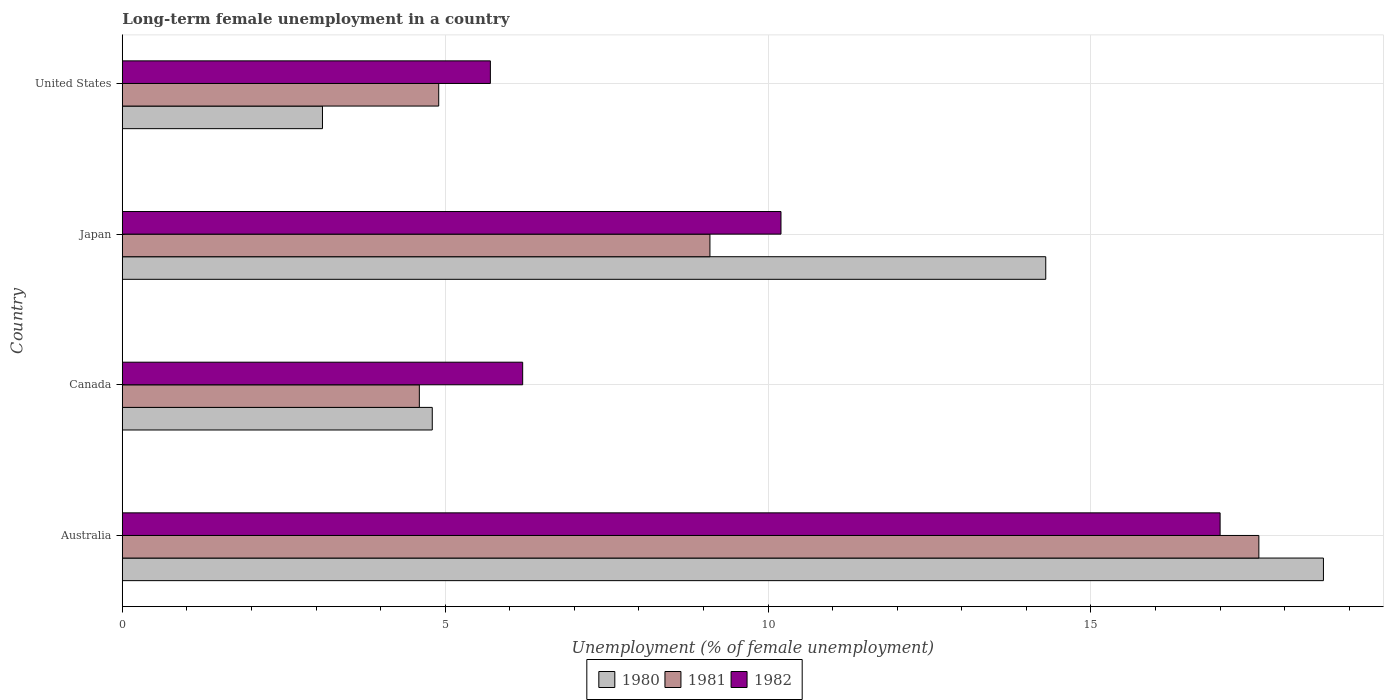How many bars are there on the 1st tick from the bottom?
Offer a very short reply. 3. In how many cases, is the number of bars for a given country not equal to the number of legend labels?
Provide a short and direct response. 0. Across all countries, what is the maximum percentage of long-term unemployed female population in 1980?
Offer a very short reply. 18.6. Across all countries, what is the minimum percentage of long-term unemployed female population in 1980?
Make the answer very short. 3.1. In which country was the percentage of long-term unemployed female population in 1981 maximum?
Your answer should be very brief. Australia. In which country was the percentage of long-term unemployed female population in 1982 minimum?
Provide a short and direct response. United States. What is the total percentage of long-term unemployed female population in 1981 in the graph?
Provide a short and direct response. 36.2. What is the difference between the percentage of long-term unemployed female population in 1980 in Australia and that in United States?
Ensure brevity in your answer.  15.5. What is the difference between the percentage of long-term unemployed female population in 1982 in United States and the percentage of long-term unemployed female population in 1981 in Australia?
Provide a short and direct response. -11.9. What is the average percentage of long-term unemployed female population in 1980 per country?
Your answer should be very brief. 10.2. What is the difference between the percentage of long-term unemployed female population in 1981 and percentage of long-term unemployed female population in 1980 in United States?
Your answer should be compact. 1.8. What is the ratio of the percentage of long-term unemployed female population in 1980 in Japan to that in United States?
Ensure brevity in your answer.  4.61. What is the difference between the highest and the second highest percentage of long-term unemployed female population in 1982?
Your answer should be very brief. 6.8. What is the difference between the highest and the lowest percentage of long-term unemployed female population in 1980?
Ensure brevity in your answer.  15.5. In how many countries, is the percentage of long-term unemployed female population in 1982 greater than the average percentage of long-term unemployed female population in 1982 taken over all countries?
Ensure brevity in your answer.  2. Is the sum of the percentage of long-term unemployed female population in 1982 in Australia and Canada greater than the maximum percentage of long-term unemployed female population in 1981 across all countries?
Make the answer very short. Yes. What does the 3rd bar from the top in Canada represents?
Make the answer very short. 1980. Is it the case that in every country, the sum of the percentage of long-term unemployed female population in 1982 and percentage of long-term unemployed female population in 1981 is greater than the percentage of long-term unemployed female population in 1980?
Offer a terse response. Yes. Are all the bars in the graph horizontal?
Provide a short and direct response. Yes. How many countries are there in the graph?
Give a very brief answer. 4. Are the values on the major ticks of X-axis written in scientific E-notation?
Offer a terse response. No. Does the graph contain any zero values?
Provide a succinct answer. No. How many legend labels are there?
Your answer should be very brief. 3. How are the legend labels stacked?
Provide a succinct answer. Horizontal. What is the title of the graph?
Provide a short and direct response. Long-term female unemployment in a country. Does "1981" appear as one of the legend labels in the graph?
Ensure brevity in your answer.  Yes. What is the label or title of the X-axis?
Your answer should be very brief. Unemployment (% of female unemployment). What is the Unemployment (% of female unemployment) in 1980 in Australia?
Keep it short and to the point. 18.6. What is the Unemployment (% of female unemployment) of 1981 in Australia?
Offer a very short reply. 17.6. What is the Unemployment (% of female unemployment) of 1982 in Australia?
Keep it short and to the point. 17. What is the Unemployment (% of female unemployment) of 1980 in Canada?
Provide a succinct answer. 4.8. What is the Unemployment (% of female unemployment) of 1981 in Canada?
Provide a succinct answer. 4.6. What is the Unemployment (% of female unemployment) in 1982 in Canada?
Keep it short and to the point. 6.2. What is the Unemployment (% of female unemployment) of 1980 in Japan?
Ensure brevity in your answer.  14.3. What is the Unemployment (% of female unemployment) in 1981 in Japan?
Offer a terse response. 9.1. What is the Unemployment (% of female unemployment) of 1982 in Japan?
Give a very brief answer. 10.2. What is the Unemployment (% of female unemployment) of 1980 in United States?
Your answer should be very brief. 3.1. What is the Unemployment (% of female unemployment) of 1981 in United States?
Offer a very short reply. 4.9. What is the Unemployment (% of female unemployment) in 1982 in United States?
Offer a terse response. 5.7. Across all countries, what is the maximum Unemployment (% of female unemployment) in 1980?
Keep it short and to the point. 18.6. Across all countries, what is the maximum Unemployment (% of female unemployment) in 1981?
Offer a terse response. 17.6. Across all countries, what is the minimum Unemployment (% of female unemployment) in 1980?
Make the answer very short. 3.1. Across all countries, what is the minimum Unemployment (% of female unemployment) in 1981?
Ensure brevity in your answer.  4.6. Across all countries, what is the minimum Unemployment (% of female unemployment) in 1982?
Your answer should be very brief. 5.7. What is the total Unemployment (% of female unemployment) of 1980 in the graph?
Your answer should be compact. 40.8. What is the total Unemployment (% of female unemployment) of 1981 in the graph?
Provide a short and direct response. 36.2. What is the total Unemployment (% of female unemployment) in 1982 in the graph?
Make the answer very short. 39.1. What is the difference between the Unemployment (% of female unemployment) of 1980 in Australia and that in Canada?
Make the answer very short. 13.8. What is the difference between the Unemployment (% of female unemployment) in 1981 in Australia and that in Japan?
Offer a very short reply. 8.5. What is the difference between the Unemployment (% of female unemployment) of 1982 in Australia and that in Japan?
Provide a succinct answer. 6.8. What is the difference between the Unemployment (% of female unemployment) of 1980 in Australia and that in United States?
Provide a short and direct response. 15.5. What is the difference between the Unemployment (% of female unemployment) of 1980 in Canada and that in United States?
Provide a short and direct response. 1.7. What is the difference between the Unemployment (% of female unemployment) in 1981 in Canada and that in United States?
Offer a very short reply. -0.3. What is the difference between the Unemployment (% of female unemployment) in 1982 in Canada and that in United States?
Offer a terse response. 0.5. What is the difference between the Unemployment (% of female unemployment) of 1981 in Japan and that in United States?
Make the answer very short. 4.2. What is the difference between the Unemployment (% of female unemployment) in 1982 in Japan and that in United States?
Offer a very short reply. 4.5. What is the difference between the Unemployment (% of female unemployment) of 1980 in Australia and the Unemployment (% of female unemployment) of 1982 in Canada?
Give a very brief answer. 12.4. What is the difference between the Unemployment (% of female unemployment) in 1981 in Australia and the Unemployment (% of female unemployment) in 1982 in Canada?
Your response must be concise. 11.4. What is the difference between the Unemployment (% of female unemployment) in 1981 in Australia and the Unemployment (% of female unemployment) in 1982 in Japan?
Ensure brevity in your answer.  7.4. What is the difference between the Unemployment (% of female unemployment) of 1980 in Australia and the Unemployment (% of female unemployment) of 1982 in United States?
Your answer should be very brief. 12.9. What is the difference between the Unemployment (% of female unemployment) of 1980 in Canada and the Unemployment (% of female unemployment) of 1982 in Japan?
Your answer should be very brief. -5.4. What is the difference between the Unemployment (% of female unemployment) of 1980 in Canada and the Unemployment (% of female unemployment) of 1981 in United States?
Offer a very short reply. -0.1. What is the difference between the Unemployment (% of female unemployment) of 1981 in Canada and the Unemployment (% of female unemployment) of 1982 in United States?
Ensure brevity in your answer.  -1.1. What is the average Unemployment (% of female unemployment) in 1980 per country?
Your response must be concise. 10.2. What is the average Unemployment (% of female unemployment) in 1981 per country?
Provide a succinct answer. 9.05. What is the average Unemployment (% of female unemployment) of 1982 per country?
Provide a short and direct response. 9.78. What is the difference between the Unemployment (% of female unemployment) of 1980 and Unemployment (% of female unemployment) of 1982 in Australia?
Your answer should be compact. 1.6. What is the difference between the Unemployment (% of female unemployment) in 1980 and Unemployment (% of female unemployment) in 1981 in Canada?
Provide a succinct answer. 0.2. What is the difference between the Unemployment (% of female unemployment) in 1980 and Unemployment (% of female unemployment) in 1982 in Canada?
Offer a very short reply. -1.4. What is the difference between the Unemployment (% of female unemployment) in 1980 and Unemployment (% of female unemployment) in 1981 in Japan?
Provide a succinct answer. 5.2. What is the difference between the Unemployment (% of female unemployment) in 1981 and Unemployment (% of female unemployment) in 1982 in Japan?
Your answer should be very brief. -1.1. What is the difference between the Unemployment (% of female unemployment) in 1980 and Unemployment (% of female unemployment) in 1982 in United States?
Offer a very short reply. -2.6. What is the ratio of the Unemployment (% of female unemployment) of 1980 in Australia to that in Canada?
Offer a terse response. 3.88. What is the ratio of the Unemployment (% of female unemployment) in 1981 in Australia to that in Canada?
Your response must be concise. 3.83. What is the ratio of the Unemployment (% of female unemployment) in 1982 in Australia to that in Canada?
Make the answer very short. 2.74. What is the ratio of the Unemployment (% of female unemployment) of 1980 in Australia to that in Japan?
Offer a very short reply. 1.3. What is the ratio of the Unemployment (% of female unemployment) of 1981 in Australia to that in Japan?
Give a very brief answer. 1.93. What is the ratio of the Unemployment (% of female unemployment) in 1980 in Australia to that in United States?
Your response must be concise. 6. What is the ratio of the Unemployment (% of female unemployment) in 1981 in Australia to that in United States?
Offer a terse response. 3.59. What is the ratio of the Unemployment (% of female unemployment) of 1982 in Australia to that in United States?
Give a very brief answer. 2.98. What is the ratio of the Unemployment (% of female unemployment) in 1980 in Canada to that in Japan?
Keep it short and to the point. 0.34. What is the ratio of the Unemployment (% of female unemployment) in 1981 in Canada to that in Japan?
Make the answer very short. 0.51. What is the ratio of the Unemployment (% of female unemployment) in 1982 in Canada to that in Japan?
Your answer should be compact. 0.61. What is the ratio of the Unemployment (% of female unemployment) of 1980 in Canada to that in United States?
Your answer should be very brief. 1.55. What is the ratio of the Unemployment (% of female unemployment) in 1981 in Canada to that in United States?
Offer a very short reply. 0.94. What is the ratio of the Unemployment (% of female unemployment) in 1982 in Canada to that in United States?
Provide a short and direct response. 1.09. What is the ratio of the Unemployment (% of female unemployment) of 1980 in Japan to that in United States?
Provide a succinct answer. 4.61. What is the ratio of the Unemployment (% of female unemployment) of 1981 in Japan to that in United States?
Keep it short and to the point. 1.86. What is the ratio of the Unemployment (% of female unemployment) of 1982 in Japan to that in United States?
Make the answer very short. 1.79. What is the difference between the highest and the second highest Unemployment (% of female unemployment) of 1980?
Provide a succinct answer. 4.3. What is the difference between the highest and the second highest Unemployment (% of female unemployment) of 1981?
Keep it short and to the point. 8.5. What is the difference between the highest and the second highest Unemployment (% of female unemployment) in 1982?
Make the answer very short. 6.8. What is the difference between the highest and the lowest Unemployment (% of female unemployment) of 1980?
Provide a short and direct response. 15.5. What is the difference between the highest and the lowest Unemployment (% of female unemployment) of 1981?
Provide a short and direct response. 13. What is the difference between the highest and the lowest Unemployment (% of female unemployment) of 1982?
Provide a succinct answer. 11.3. 